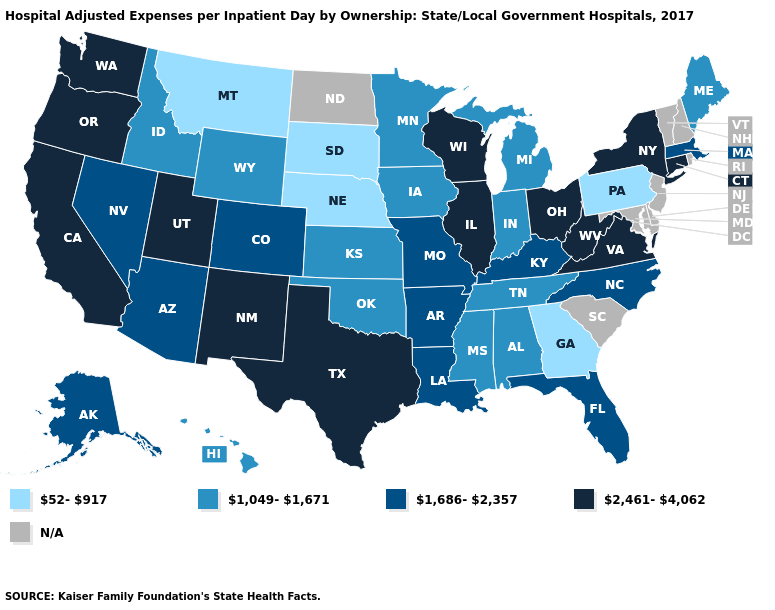How many symbols are there in the legend?
Write a very short answer. 5. Which states have the highest value in the USA?
Give a very brief answer. California, Connecticut, Illinois, New Mexico, New York, Ohio, Oregon, Texas, Utah, Virginia, Washington, West Virginia, Wisconsin. Name the states that have a value in the range 1,686-2,357?
Short answer required. Alaska, Arizona, Arkansas, Colorado, Florida, Kentucky, Louisiana, Massachusetts, Missouri, Nevada, North Carolina. What is the highest value in states that border Montana?
Short answer required. 1,049-1,671. What is the value of West Virginia?
Answer briefly. 2,461-4,062. What is the value of New Mexico?
Answer briefly. 2,461-4,062. How many symbols are there in the legend?
Give a very brief answer. 5. How many symbols are there in the legend?
Short answer required. 5. Name the states that have a value in the range 1,686-2,357?
Short answer required. Alaska, Arizona, Arkansas, Colorado, Florida, Kentucky, Louisiana, Massachusetts, Missouri, Nevada, North Carolina. What is the value of North Dakota?
Write a very short answer. N/A. Does the map have missing data?
Answer briefly. Yes. Which states hav the highest value in the West?
Concise answer only. California, New Mexico, Oregon, Utah, Washington. What is the value of Iowa?
Concise answer only. 1,049-1,671. 